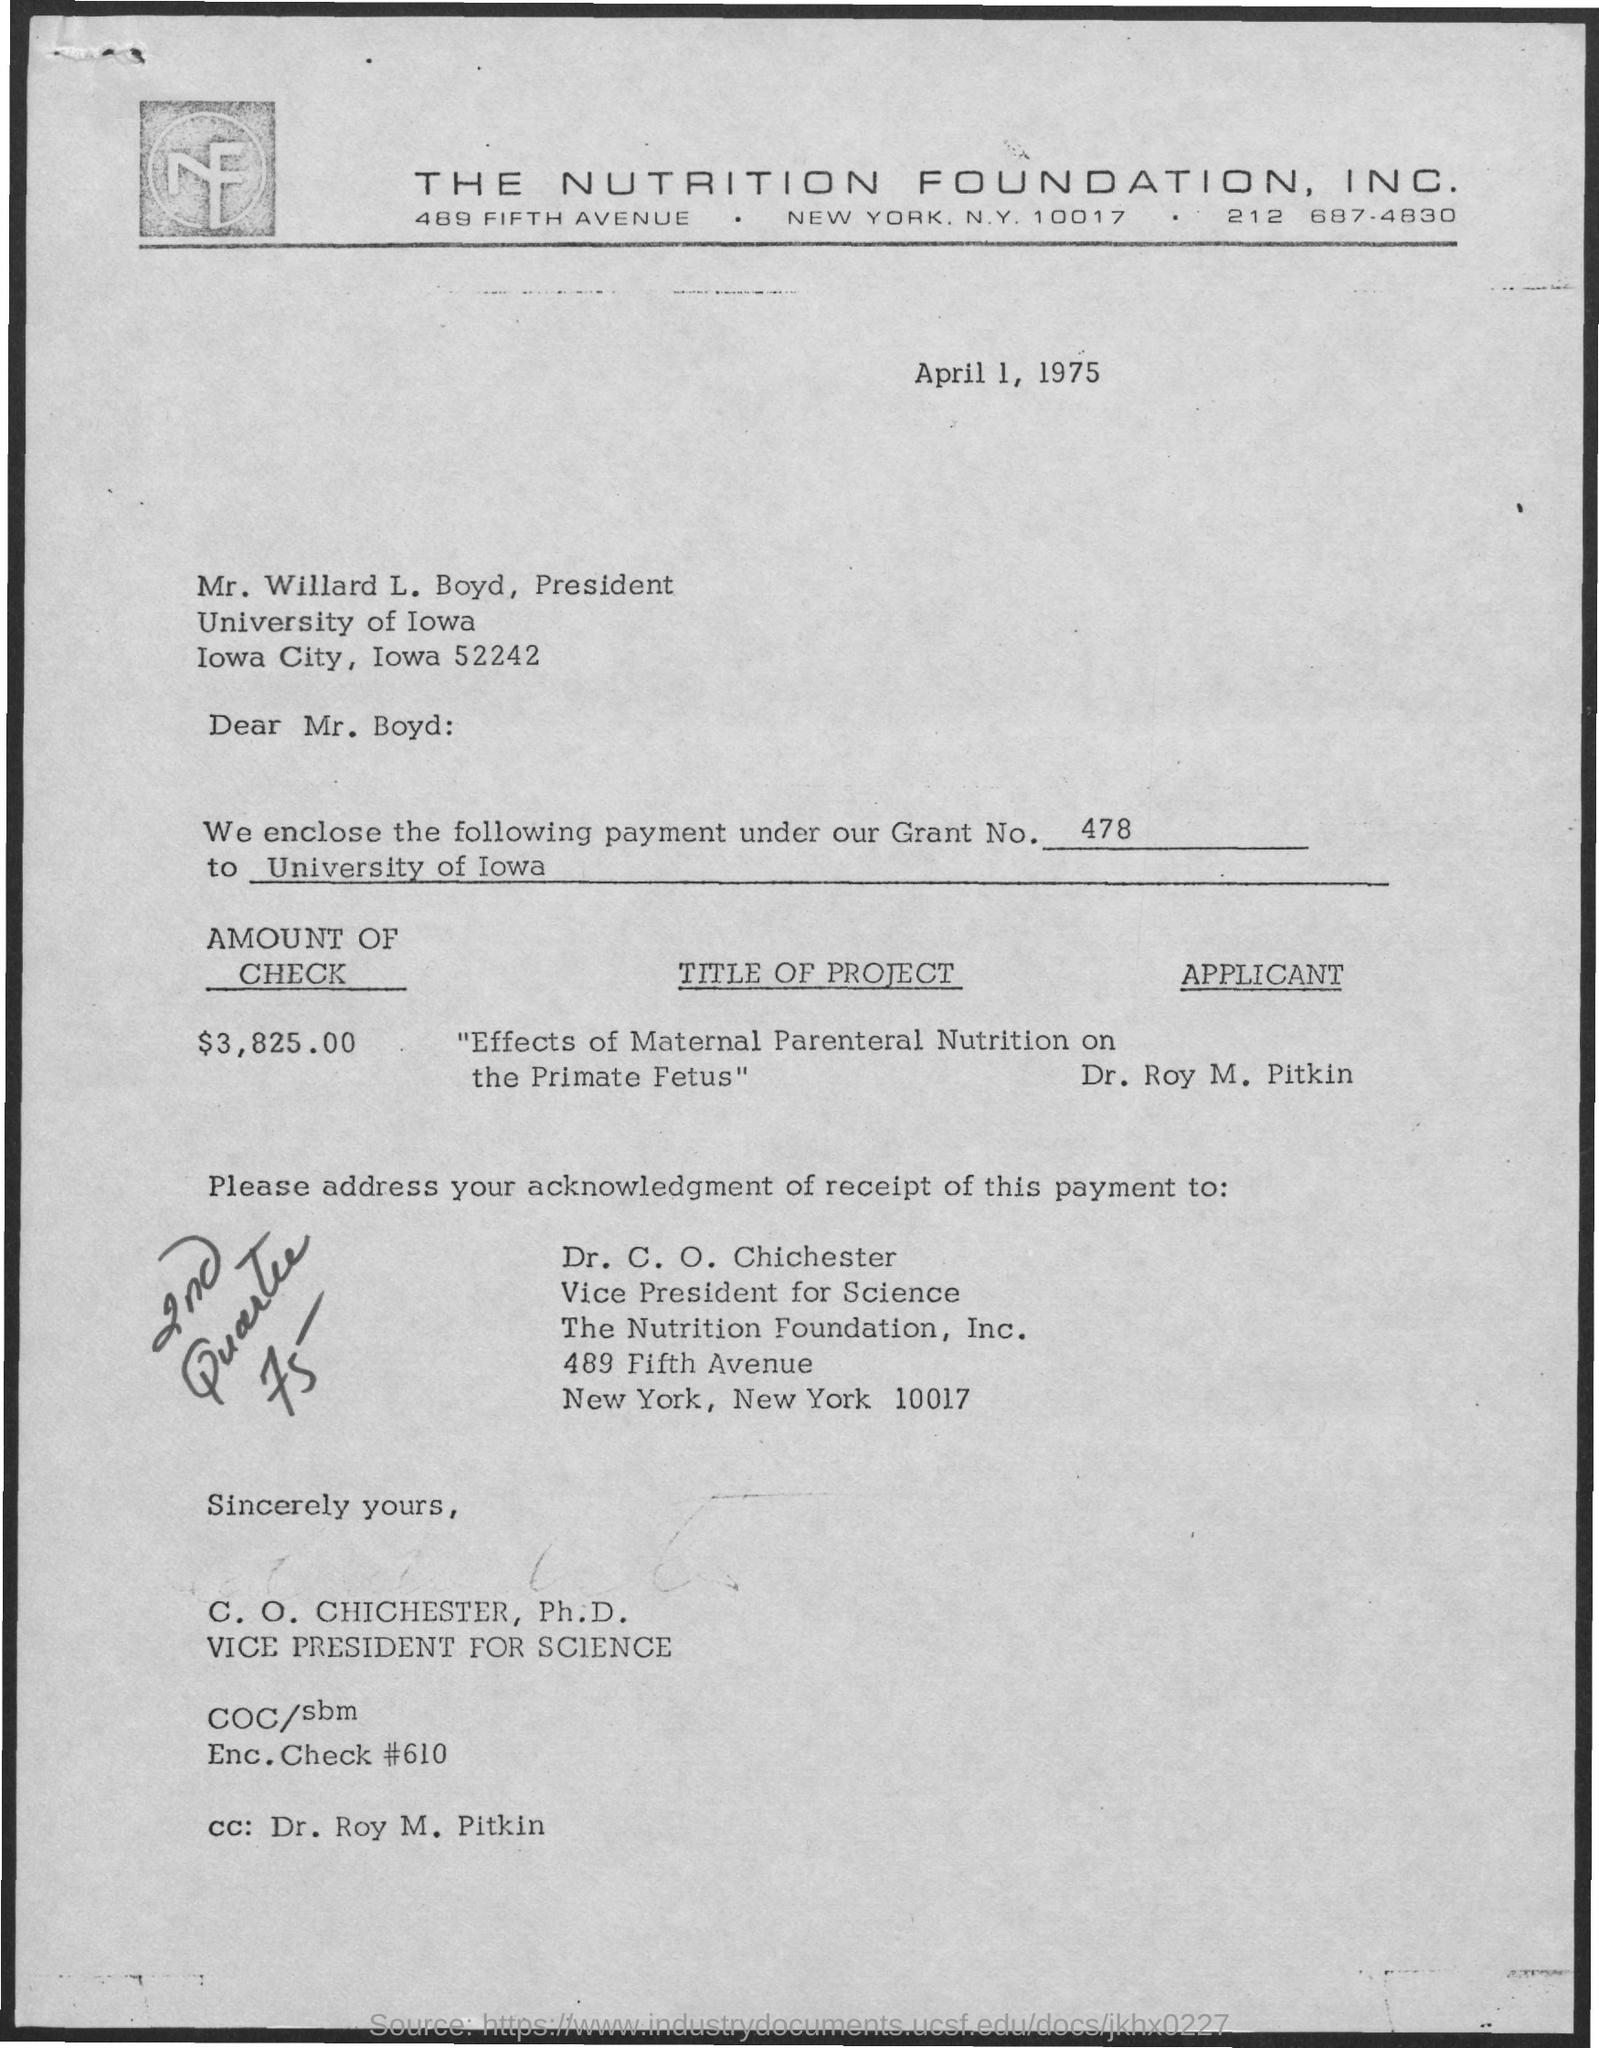Identify some key points in this picture. The Nutrition Foundation Inc. is located in New York City. Dr. Roy M. Pitkin is mentioned in the CC. The President's name is Mr. Willard L. Boyd. The name of the applicant is Dr. Roy M. Pitkin. What grant number is mentioned? 478... 